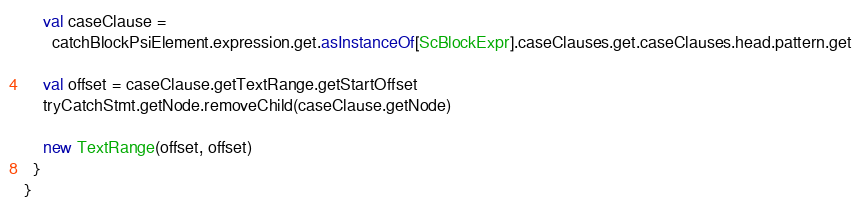<code> <loc_0><loc_0><loc_500><loc_500><_Scala_>    val caseClause =
      catchBlockPsiElement.expression.get.asInstanceOf[ScBlockExpr].caseClauses.get.caseClauses.head.pattern.get

    val offset = caseClause.getTextRange.getStartOffset
    tryCatchStmt.getNode.removeChild(caseClause.getNode)

    new TextRange(offset, offset)
  }
}
</code> 